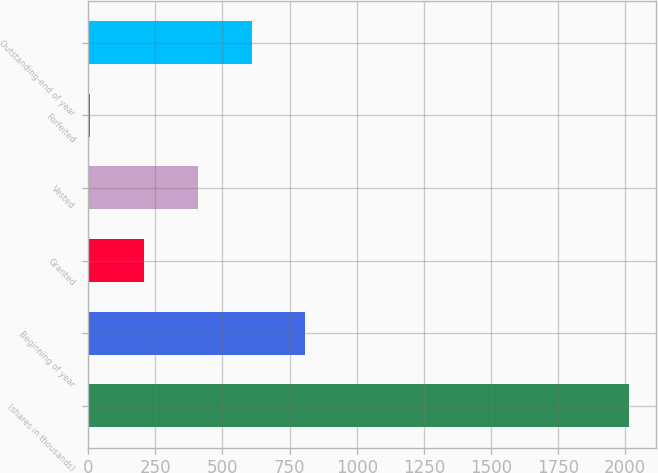Convert chart to OTSL. <chart><loc_0><loc_0><loc_500><loc_500><bar_chart><fcel>(shares in thousands)<fcel>Beginning of year<fcel>Granted<fcel>Vested<fcel>Forfeited<fcel>Outstanding-end of year<nl><fcel>2012<fcel>809<fcel>207.5<fcel>408<fcel>7<fcel>608.5<nl></chart> 